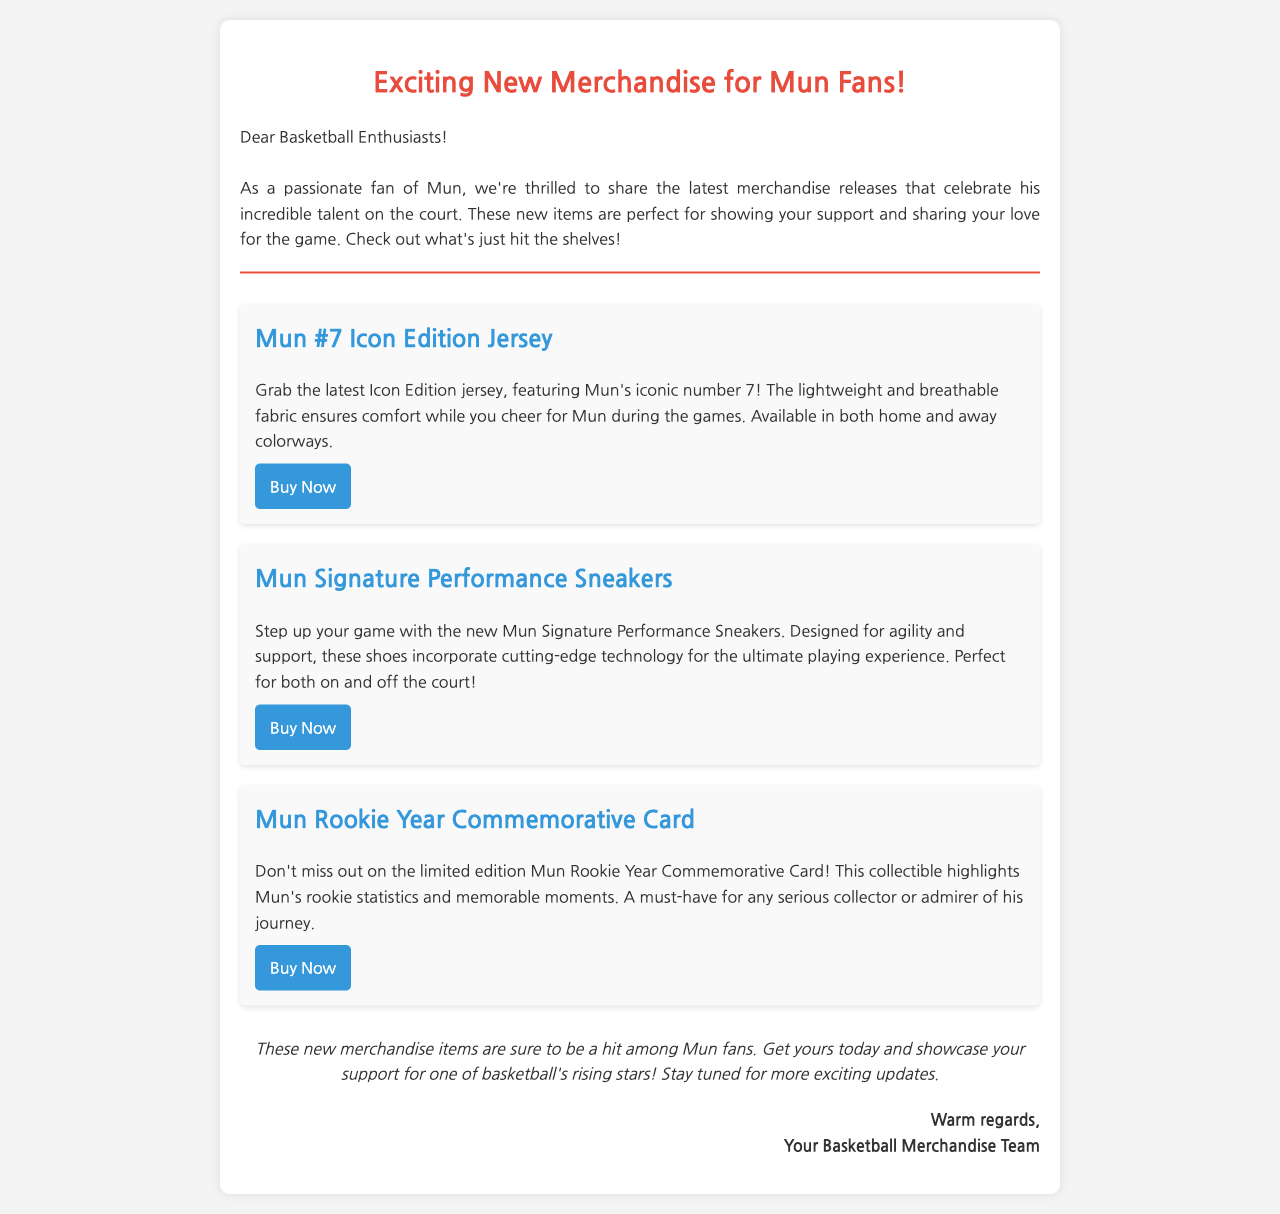What is the title of the email? The title of the email is prominently displayed at the top, announcing the focus on new merchandise for fans.
Answer: Exciting New Merchandise for Mun Fans! What is Mun's jersey number featured in the new merchandise? The document specifies that the jerseys feature Mun's iconic number.
Answer: 7 What type of sneakers are being released? The document details the release of new sneakers designed for performance and support.
Answer: Signature Performance Sneakers What item emphasizes Mun's rookie statistics? The document mentions a collectible card that commemorates Mun's rookie year.
Answer: Rookie Year Commemorative Card How many types of merchandise are listed in the document? The document describes three distinct merchandise items being released for fans.
Answer: 3 What colorways are available for the jersey? The document states that the jersey is available in different styles for fans to choose from.
Answer: Home and away What is the intended use for the new sneakers? The document highlights the sneakers' design, making them suitable for specific scenarios related to basketball.
Answer: On and off the court What is the tone of the concluding remarks in the email? The conclusion expresses encouragement for fans to buy the merchandise, reflecting an enthusiastic tone.
Answer: Supportive 